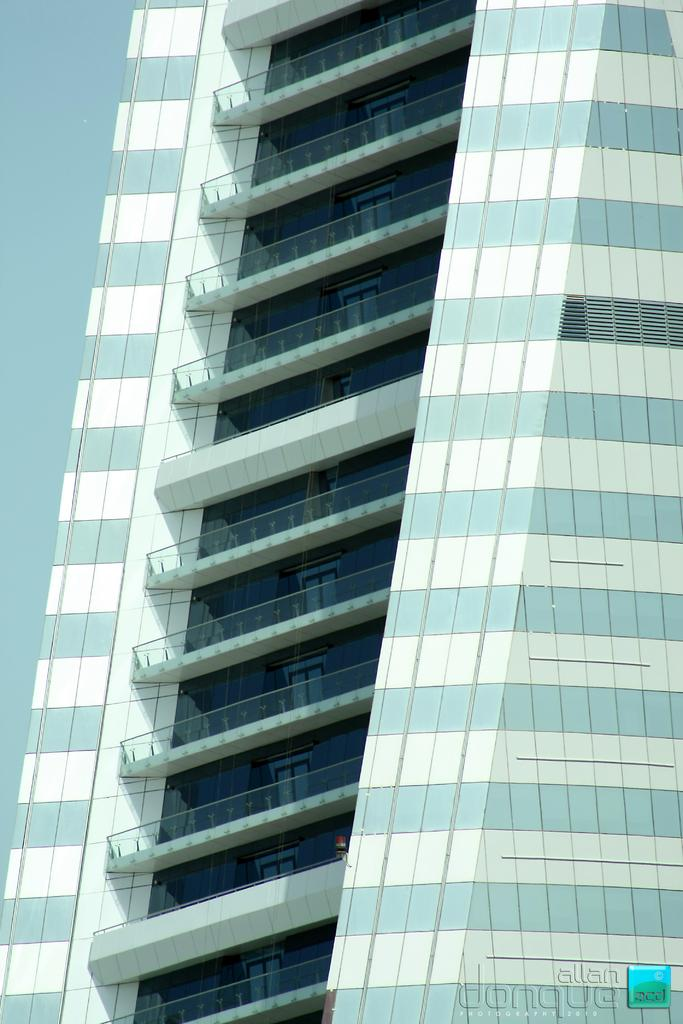What is the main subject in the front of the image? There is a building in the front of the image. What time is the ball being thrown in the image? There is no ball present in the image, so it is not possible to determine the time of a ball being thrown. 